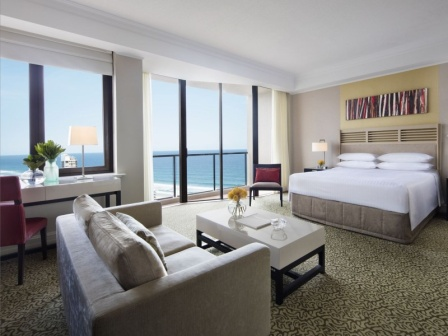Can you imagine a story taking place in this room? Be creative! In this luxurious hotel room, a world-renowned artist finds inspiration from the ocean view for their next masterpiece. They spend their days painting vibrant abstract pieces, similar to the one above the bed, and their nights contemplating life while sitting on the balcony, the sound of waves providing a soothing backdrop. One evening, while gazing at the horizon, they notice a flicker of light far out at sea. Intrigued, they embark on an unexpected adventure to uncover the mystery of the distant beacon, leading to a whirlwind of discoveries that change their life forever. 